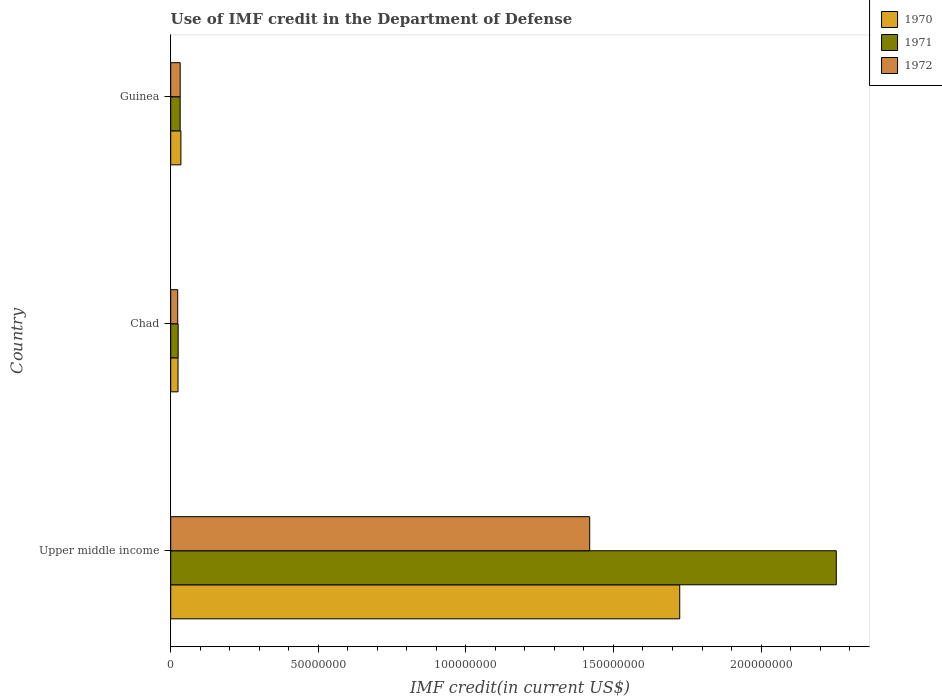How many different coloured bars are there?
Offer a very short reply. 3. Are the number of bars per tick equal to the number of legend labels?
Make the answer very short. Yes. Are the number of bars on each tick of the Y-axis equal?
Make the answer very short. Yes. What is the label of the 3rd group of bars from the top?
Your answer should be compact. Upper middle income. In how many cases, is the number of bars for a given country not equal to the number of legend labels?
Offer a very short reply. 0. What is the IMF credit in the Department of Defense in 1970 in Chad?
Your answer should be very brief. 2.47e+06. Across all countries, what is the maximum IMF credit in the Department of Defense in 1971?
Ensure brevity in your answer.  2.25e+08. Across all countries, what is the minimum IMF credit in the Department of Defense in 1971?
Ensure brevity in your answer.  2.52e+06. In which country was the IMF credit in the Department of Defense in 1972 maximum?
Your answer should be compact. Upper middle income. In which country was the IMF credit in the Department of Defense in 1972 minimum?
Provide a succinct answer. Chad. What is the total IMF credit in the Department of Defense in 1970 in the graph?
Your response must be concise. 1.78e+08. What is the difference between the IMF credit in the Department of Defense in 1971 in Chad and that in Guinea?
Keep it short and to the point. -6.84e+05. What is the difference between the IMF credit in the Department of Defense in 1972 in Chad and the IMF credit in the Department of Defense in 1970 in Guinea?
Give a very brief answer. -1.08e+06. What is the average IMF credit in the Department of Defense in 1971 per country?
Keep it short and to the point. 7.71e+07. What is the difference between the IMF credit in the Department of Defense in 1971 and IMF credit in the Department of Defense in 1970 in Chad?
Your response must be concise. 4.90e+04. In how many countries, is the IMF credit in the Department of Defense in 1972 greater than 60000000 US$?
Provide a succinct answer. 1. What is the ratio of the IMF credit in the Department of Defense in 1970 in Chad to that in Guinea?
Provide a short and direct response. 0.72. Is the difference between the IMF credit in the Department of Defense in 1971 in Guinea and Upper middle income greater than the difference between the IMF credit in the Department of Defense in 1970 in Guinea and Upper middle income?
Your answer should be very brief. No. What is the difference between the highest and the second highest IMF credit in the Department of Defense in 1970?
Keep it short and to the point. 1.69e+08. What is the difference between the highest and the lowest IMF credit in the Department of Defense in 1971?
Keep it short and to the point. 2.23e+08. Is the sum of the IMF credit in the Department of Defense in 1970 in Guinea and Upper middle income greater than the maximum IMF credit in the Department of Defense in 1972 across all countries?
Provide a succinct answer. Yes. What does the 1st bar from the top in Chad represents?
Offer a very short reply. 1972. What does the 1st bar from the bottom in Chad represents?
Provide a succinct answer. 1970. How many bars are there?
Offer a very short reply. 9. Are all the bars in the graph horizontal?
Your answer should be compact. Yes. How many countries are there in the graph?
Your response must be concise. 3. What is the difference between two consecutive major ticks on the X-axis?
Your answer should be very brief. 5.00e+07. Does the graph contain any zero values?
Offer a very short reply. No. Does the graph contain grids?
Give a very brief answer. No. How many legend labels are there?
Keep it short and to the point. 3. What is the title of the graph?
Offer a very short reply. Use of IMF credit in the Department of Defense. Does "2015" appear as one of the legend labels in the graph?
Provide a succinct answer. No. What is the label or title of the X-axis?
Provide a short and direct response. IMF credit(in current US$). What is the label or title of the Y-axis?
Make the answer very short. Country. What is the IMF credit(in current US$) in 1970 in Upper middle income?
Offer a very short reply. 1.72e+08. What is the IMF credit(in current US$) of 1971 in Upper middle income?
Your response must be concise. 2.25e+08. What is the IMF credit(in current US$) in 1972 in Upper middle income?
Your answer should be very brief. 1.42e+08. What is the IMF credit(in current US$) in 1970 in Chad?
Give a very brief answer. 2.47e+06. What is the IMF credit(in current US$) of 1971 in Chad?
Make the answer very short. 2.52e+06. What is the IMF credit(in current US$) in 1972 in Chad?
Provide a succinct answer. 2.37e+06. What is the IMF credit(in current US$) in 1970 in Guinea?
Offer a very short reply. 3.45e+06. What is the IMF credit(in current US$) in 1971 in Guinea?
Offer a terse response. 3.20e+06. What is the IMF credit(in current US$) of 1972 in Guinea?
Ensure brevity in your answer.  3.20e+06. Across all countries, what is the maximum IMF credit(in current US$) of 1970?
Give a very brief answer. 1.72e+08. Across all countries, what is the maximum IMF credit(in current US$) in 1971?
Offer a very short reply. 2.25e+08. Across all countries, what is the maximum IMF credit(in current US$) of 1972?
Your answer should be compact. 1.42e+08. Across all countries, what is the minimum IMF credit(in current US$) in 1970?
Offer a terse response. 2.47e+06. Across all countries, what is the minimum IMF credit(in current US$) in 1971?
Keep it short and to the point. 2.52e+06. Across all countries, what is the minimum IMF credit(in current US$) in 1972?
Keep it short and to the point. 2.37e+06. What is the total IMF credit(in current US$) of 1970 in the graph?
Make the answer very short. 1.78e+08. What is the total IMF credit(in current US$) in 1971 in the graph?
Provide a short and direct response. 2.31e+08. What is the total IMF credit(in current US$) in 1972 in the graph?
Your response must be concise. 1.48e+08. What is the difference between the IMF credit(in current US$) in 1970 in Upper middle income and that in Chad?
Offer a very short reply. 1.70e+08. What is the difference between the IMF credit(in current US$) of 1971 in Upper middle income and that in Chad?
Ensure brevity in your answer.  2.23e+08. What is the difference between the IMF credit(in current US$) of 1972 in Upper middle income and that in Chad?
Your response must be concise. 1.40e+08. What is the difference between the IMF credit(in current US$) in 1970 in Upper middle income and that in Guinea?
Provide a short and direct response. 1.69e+08. What is the difference between the IMF credit(in current US$) in 1971 in Upper middle income and that in Guinea?
Ensure brevity in your answer.  2.22e+08. What is the difference between the IMF credit(in current US$) of 1972 in Upper middle income and that in Guinea?
Ensure brevity in your answer.  1.39e+08. What is the difference between the IMF credit(in current US$) of 1970 in Chad and that in Guinea?
Your answer should be compact. -9.80e+05. What is the difference between the IMF credit(in current US$) in 1971 in Chad and that in Guinea?
Offer a terse response. -6.84e+05. What is the difference between the IMF credit(in current US$) of 1972 in Chad and that in Guinea?
Your answer should be very brief. -8.36e+05. What is the difference between the IMF credit(in current US$) of 1970 in Upper middle income and the IMF credit(in current US$) of 1971 in Chad?
Provide a succinct answer. 1.70e+08. What is the difference between the IMF credit(in current US$) of 1970 in Upper middle income and the IMF credit(in current US$) of 1972 in Chad?
Your answer should be compact. 1.70e+08. What is the difference between the IMF credit(in current US$) in 1971 in Upper middle income and the IMF credit(in current US$) in 1972 in Chad?
Your response must be concise. 2.23e+08. What is the difference between the IMF credit(in current US$) in 1970 in Upper middle income and the IMF credit(in current US$) in 1971 in Guinea?
Ensure brevity in your answer.  1.69e+08. What is the difference between the IMF credit(in current US$) of 1970 in Upper middle income and the IMF credit(in current US$) of 1972 in Guinea?
Your answer should be compact. 1.69e+08. What is the difference between the IMF credit(in current US$) of 1971 in Upper middle income and the IMF credit(in current US$) of 1972 in Guinea?
Offer a terse response. 2.22e+08. What is the difference between the IMF credit(in current US$) of 1970 in Chad and the IMF credit(in current US$) of 1971 in Guinea?
Your answer should be compact. -7.33e+05. What is the difference between the IMF credit(in current US$) in 1970 in Chad and the IMF credit(in current US$) in 1972 in Guinea?
Give a very brief answer. -7.33e+05. What is the difference between the IMF credit(in current US$) in 1971 in Chad and the IMF credit(in current US$) in 1972 in Guinea?
Keep it short and to the point. -6.84e+05. What is the average IMF credit(in current US$) in 1970 per country?
Offer a terse response. 5.95e+07. What is the average IMF credit(in current US$) in 1971 per country?
Provide a short and direct response. 7.71e+07. What is the average IMF credit(in current US$) of 1972 per country?
Your answer should be very brief. 4.92e+07. What is the difference between the IMF credit(in current US$) of 1970 and IMF credit(in current US$) of 1971 in Upper middle income?
Give a very brief answer. -5.30e+07. What is the difference between the IMF credit(in current US$) in 1970 and IMF credit(in current US$) in 1972 in Upper middle income?
Keep it short and to the point. 3.05e+07. What is the difference between the IMF credit(in current US$) of 1971 and IMF credit(in current US$) of 1972 in Upper middle income?
Ensure brevity in your answer.  8.35e+07. What is the difference between the IMF credit(in current US$) of 1970 and IMF credit(in current US$) of 1971 in Chad?
Your response must be concise. -4.90e+04. What is the difference between the IMF credit(in current US$) in 1970 and IMF credit(in current US$) in 1972 in Chad?
Keep it short and to the point. 1.03e+05. What is the difference between the IMF credit(in current US$) of 1971 and IMF credit(in current US$) of 1972 in Chad?
Provide a succinct answer. 1.52e+05. What is the difference between the IMF credit(in current US$) in 1970 and IMF credit(in current US$) in 1971 in Guinea?
Give a very brief answer. 2.47e+05. What is the difference between the IMF credit(in current US$) of 1970 and IMF credit(in current US$) of 1972 in Guinea?
Your answer should be compact. 2.47e+05. What is the ratio of the IMF credit(in current US$) of 1970 in Upper middle income to that in Chad?
Your answer should be compact. 69.82. What is the ratio of the IMF credit(in current US$) in 1971 in Upper middle income to that in Chad?
Give a very brief answer. 89.51. What is the ratio of the IMF credit(in current US$) of 1972 in Upper middle income to that in Chad?
Provide a short and direct response. 59.97. What is the ratio of the IMF credit(in current US$) of 1970 in Upper middle income to that in Guinea?
Provide a succinct answer. 49.99. What is the ratio of the IMF credit(in current US$) of 1971 in Upper middle income to that in Guinea?
Your answer should be very brief. 70.4. What is the ratio of the IMF credit(in current US$) of 1972 in Upper middle income to that in Guinea?
Your response must be concise. 44.32. What is the ratio of the IMF credit(in current US$) of 1970 in Chad to that in Guinea?
Offer a terse response. 0.72. What is the ratio of the IMF credit(in current US$) in 1971 in Chad to that in Guinea?
Provide a short and direct response. 0.79. What is the ratio of the IMF credit(in current US$) in 1972 in Chad to that in Guinea?
Your answer should be very brief. 0.74. What is the difference between the highest and the second highest IMF credit(in current US$) of 1970?
Your response must be concise. 1.69e+08. What is the difference between the highest and the second highest IMF credit(in current US$) in 1971?
Offer a terse response. 2.22e+08. What is the difference between the highest and the second highest IMF credit(in current US$) in 1972?
Provide a short and direct response. 1.39e+08. What is the difference between the highest and the lowest IMF credit(in current US$) in 1970?
Make the answer very short. 1.70e+08. What is the difference between the highest and the lowest IMF credit(in current US$) in 1971?
Provide a short and direct response. 2.23e+08. What is the difference between the highest and the lowest IMF credit(in current US$) of 1972?
Your response must be concise. 1.40e+08. 